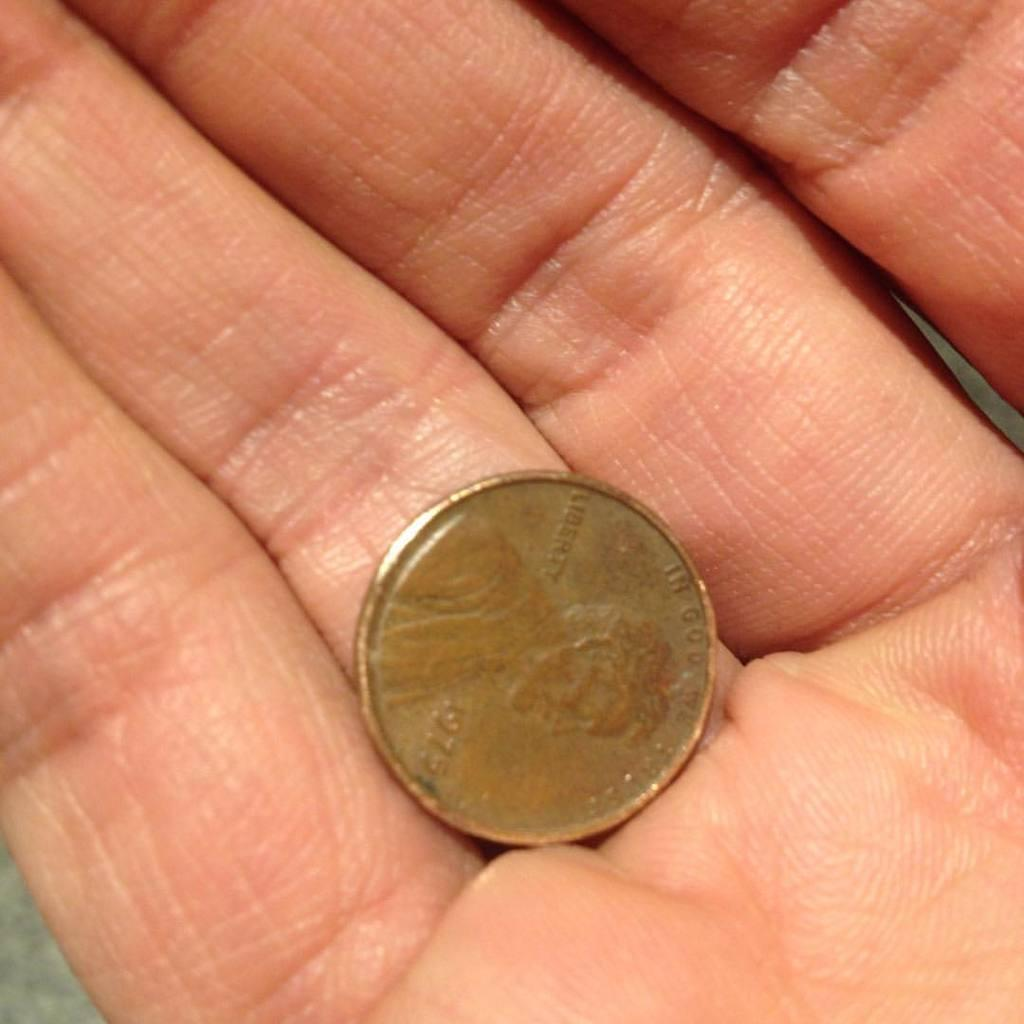<image>
Share a concise interpretation of the image provided. Gold coin that says liberty on it and a face of a president. 